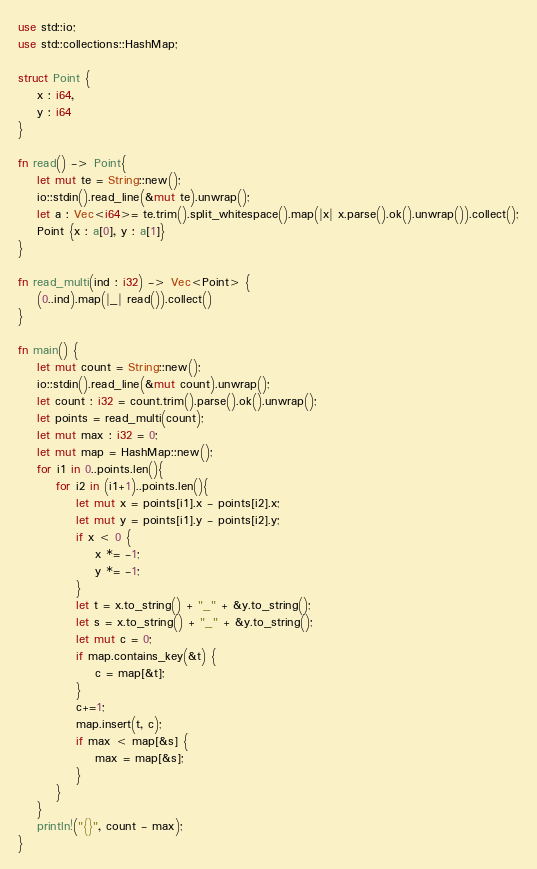<code> <loc_0><loc_0><loc_500><loc_500><_Rust_>use std::io;
use std::collections::HashMap;

struct Point {
    x : i64,
    y : i64
}

fn read() -> Point{
    let mut te = String::new();
    io::stdin().read_line(&mut te).unwrap();
    let a : Vec<i64>= te.trim().split_whitespace().map(|x| x.parse().ok().unwrap()).collect();
    Point {x : a[0], y : a[1]}
}

fn read_multi(ind : i32) -> Vec<Point> {
    (0..ind).map(|_| read()).collect()
}

fn main() {
    let mut count = String::new();
    io::stdin().read_line(&mut count).unwrap();
    let count : i32 = count.trim().parse().ok().unwrap();
    let points = read_multi(count);
    let mut max : i32 = 0;
    let mut map = HashMap::new();
    for i1 in 0..points.len(){
        for i2 in (i1+1)..points.len(){
            let mut x = points[i1].x - points[i2].x;
            let mut y = points[i1].y - points[i2].y;
            if x < 0 {
                x *= -1;
                y *= -1;
            }
            let t = x.to_string() + "_" + &y.to_string();
            let s = x.to_string() + "_" + &y.to_string();
            let mut c = 0;
            if map.contains_key(&t) {
                c = map[&t];
            }
            c+=1;
            map.insert(t, c);
            if max < map[&s] {
                max = map[&s];
            }
        }
    }
    println!("{}", count - max);
}

</code> 